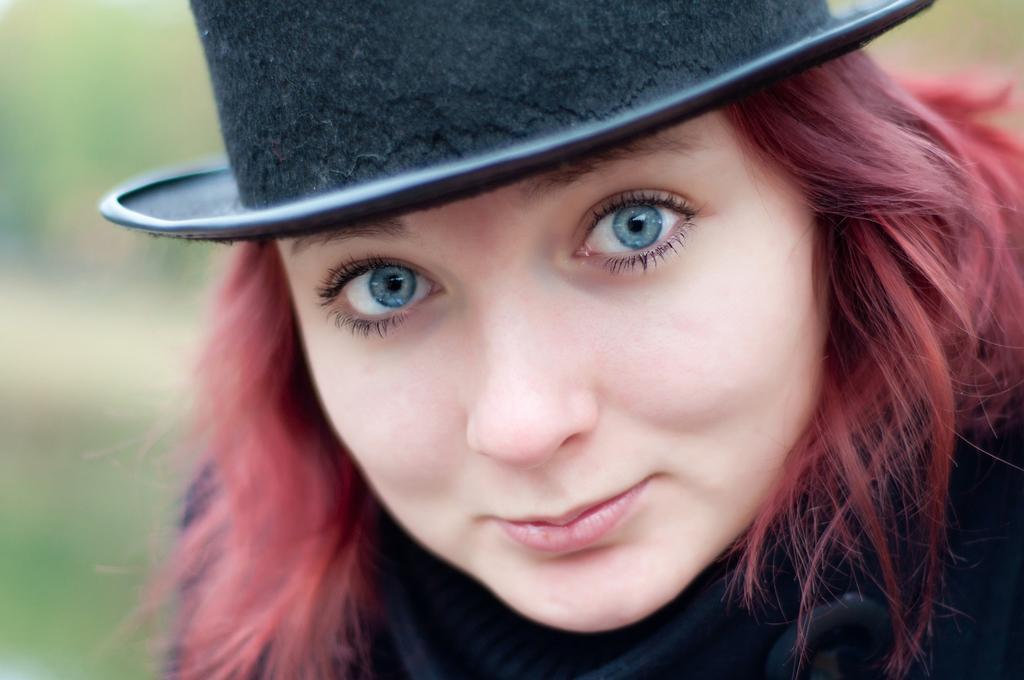In one or two sentences, can you explain what this image depicts? There is a lady wearing black hat with blue eyes. In the background it is blurred. 